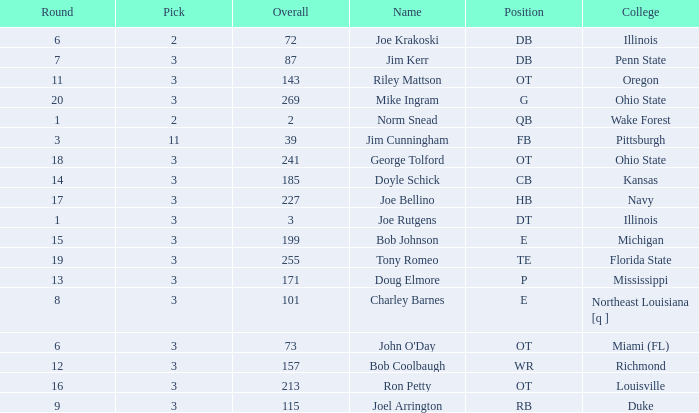How many rounds have john o'day as the name, and a pick less than 3? None. 